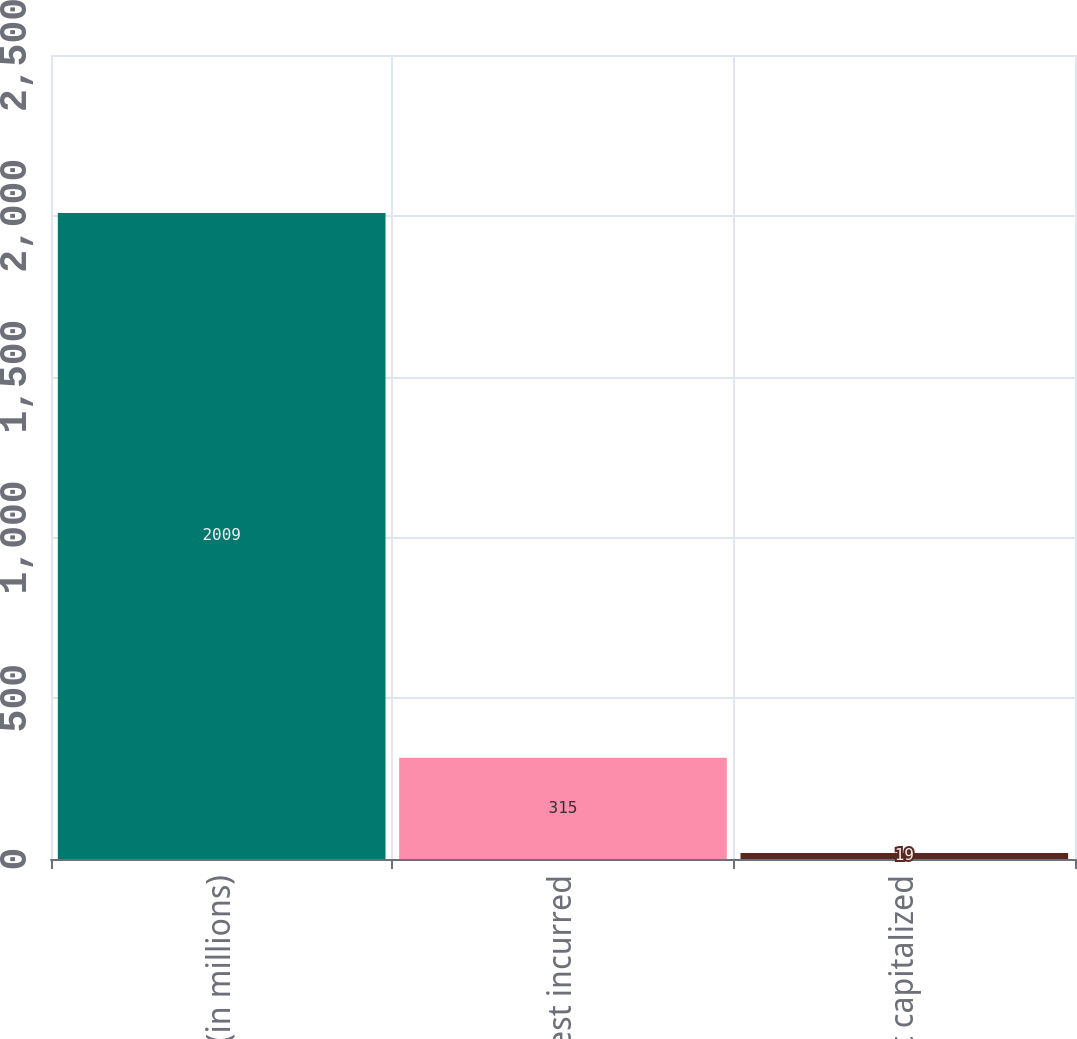Convert chart to OTSL. <chart><loc_0><loc_0><loc_500><loc_500><bar_chart><fcel>(in millions)<fcel>Interest incurred<fcel>Interest capitalized<nl><fcel>2009<fcel>315<fcel>19<nl></chart> 